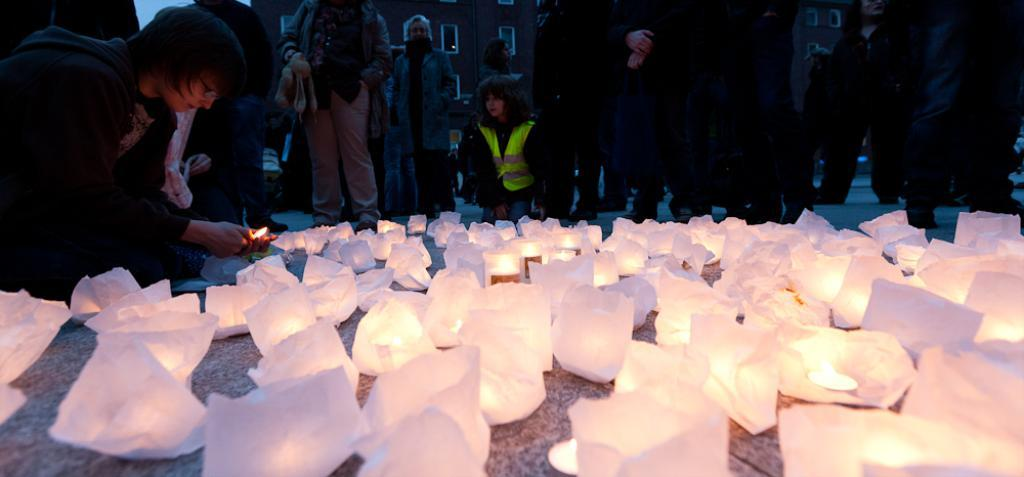What are the people in the image wearing? The persons in the image are wearing clothes. What can be seen on the ground in the image? There are sky lanterns on the ground. What can be seen in the distance in the image? There are buildings visible in the background of the image. What book is the person reading in the image? There is no person reading a book in the image; the focus is on the persons wearing clothes and the sky lanterns on the ground. 